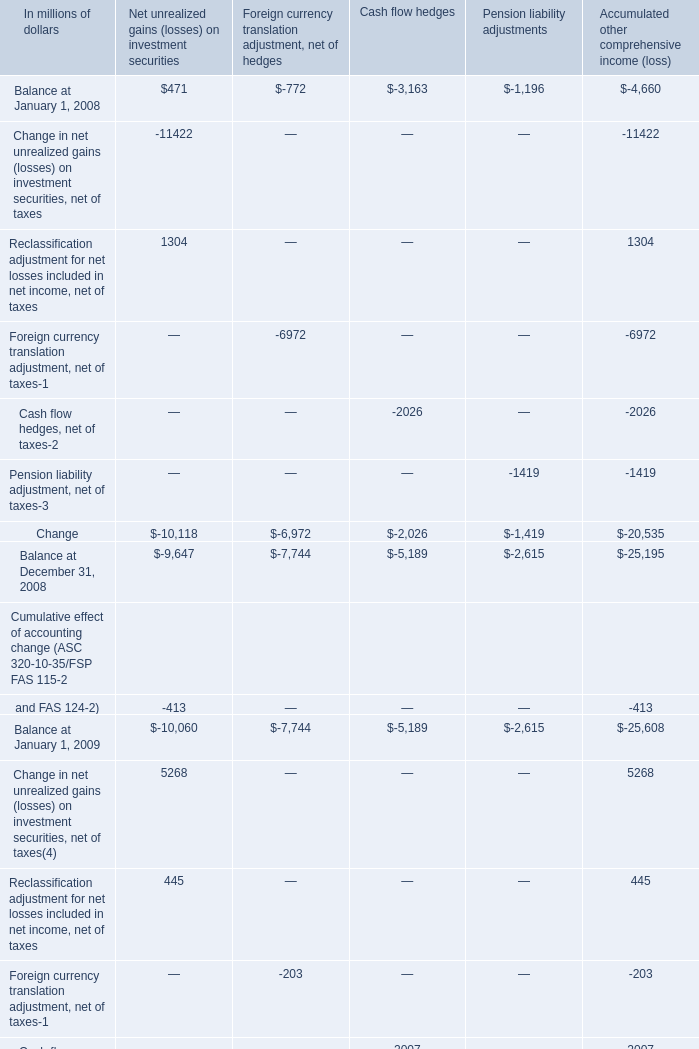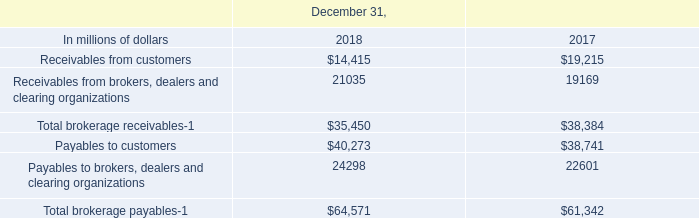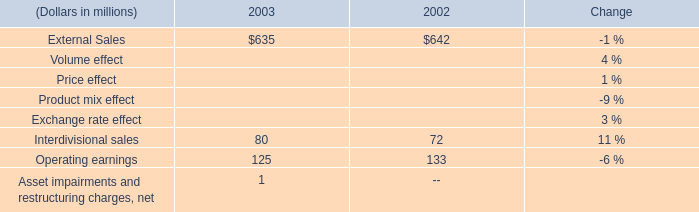What's the average of Balance at January 1, 2008 of Pension liability adjustments, and Receivables from customers of December 31, 2017 ? 
Computations: ((1196.0 + 19215.0) / 2)
Answer: 10205.5. 